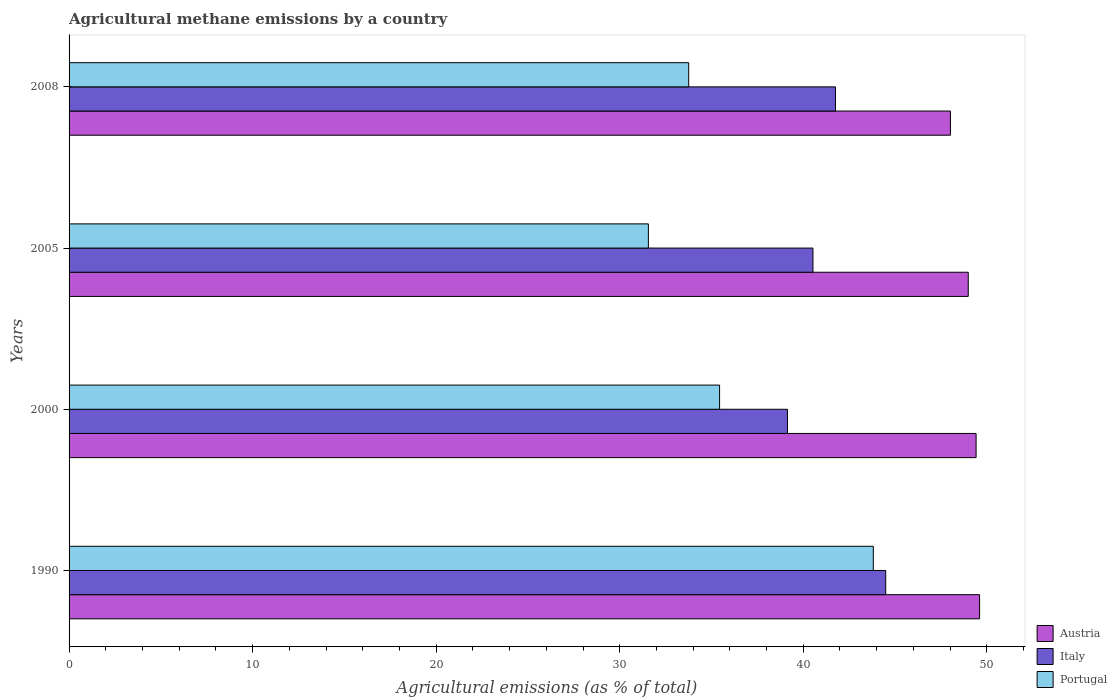How many groups of bars are there?
Keep it short and to the point. 4. How many bars are there on the 4th tick from the top?
Your response must be concise. 3. What is the label of the 4th group of bars from the top?
Provide a succinct answer. 1990. In how many cases, is the number of bars for a given year not equal to the number of legend labels?
Provide a short and direct response. 0. What is the amount of agricultural methane emitted in Portugal in 2000?
Give a very brief answer. 35.44. Across all years, what is the maximum amount of agricultural methane emitted in Austria?
Offer a terse response. 49.61. Across all years, what is the minimum amount of agricultural methane emitted in Italy?
Give a very brief answer. 39.14. In which year was the amount of agricultural methane emitted in Austria maximum?
Offer a very short reply. 1990. What is the total amount of agricultural methane emitted in Portugal in the graph?
Your response must be concise. 144.58. What is the difference between the amount of agricultural methane emitted in Portugal in 1990 and that in 2000?
Make the answer very short. 8.38. What is the difference between the amount of agricultural methane emitted in Austria in 2000 and the amount of agricultural methane emitted in Portugal in 2008?
Keep it short and to the point. 15.66. What is the average amount of agricultural methane emitted in Portugal per year?
Provide a short and direct response. 36.14. In the year 1990, what is the difference between the amount of agricultural methane emitted in Italy and amount of agricultural methane emitted in Austria?
Ensure brevity in your answer.  -5.11. In how many years, is the amount of agricultural methane emitted in Italy greater than 44 %?
Your answer should be compact. 1. What is the ratio of the amount of agricultural methane emitted in Portugal in 2005 to that in 2008?
Your response must be concise. 0.93. Is the difference between the amount of agricultural methane emitted in Italy in 1990 and 2000 greater than the difference between the amount of agricultural methane emitted in Austria in 1990 and 2000?
Make the answer very short. Yes. What is the difference between the highest and the second highest amount of agricultural methane emitted in Portugal?
Offer a very short reply. 8.38. What is the difference between the highest and the lowest amount of agricultural methane emitted in Portugal?
Your answer should be very brief. 12.26. Is the sum of the amount of agricultural methane emitted in Italy in 2000 and 2005 greater than the maximum amount of agricultural methane emitted in Portugal across all years?
Make the answer very short. Yes. What does the 3rd bar from the top in 2005 represents?
Provide a short and direct response. Austria. How many bars are there?
Offer a terse response. 12. Are all the bars in the graph horizontal?
Provide a succinct answer. Yes. What is the difference between two consecutive major ticks on the X-axis?
Ensure brevity in your answer.  10. Are the values on the major ticks of X-axis written in scientific E-notation?
Make the answer very short. No. Does the graph contain grids?
Offer a very short reply. No. Where does the legend appear in the graph?
Your answer should be compact. Bottom right. How many legend labels are there?
Provide a short and direct response. 3. How are the legend labels stacked?
Ensure brevity in your answer.  Vertical. What is the title of the graph?
Keep it short and to the point. Agricultural methane emissions by a country. What is the label or title of the X-axis?
Keep it short and to the point. Agricultural emissions (as % of total). What is the label or title of the Y-axis?
Provide a short and direct response. Years. What is the Agricultural emissions (as % of total) in Austria in 1990?
Provide a succinct answer. 49.61. What is the Agricultural emissions (as % of total) in Italy in 1990?
Offer a terse response. 44.49. What is the Agricultural emissions (as % of total) in Portugal in 1990?
Keep it short and to the point. 43.82. What is the Agricultural emissions (as % of total) in Austria in 2000?
Offer a terse response. 49.42. What is the Agricultural emissions (as % of total) of Italy in 2000?
Provide a short and direct response. 39.14. What is the Agricultural emissions (as % of total) in Portugal in 2000?
Provide a succinct answer. 35.44. What is the Agricultural emissions (as % of total) in Austria in 2005?
Offer a very short reply. 48.99. What is the Agricultural emissions (as % of total) in Italy in 2005?
Provide a succinct answer. 40.53. What is the Agricultural emissions (as % of total) of Portugal in 2005?
Provide a succinct answer. 31.56. What is the Agricultural emissions (as % of total) of Austria in 2008?
Offer a terse response. 48.02. What is the Agricultural emissions (as % of total) of Italy in 2008?
Keep it short and to the point. 41.76. What is the Agricultural emissions (as % of total) in Portugal in 2008?
Provide a succinct answer. 33.76. Across all years, what is the maximum Agricultural emissions (as % of total) of Austria?
Provide a succinct answer. 49.61. Across all years, what is the maximum Agricultural emissions (as % of total) of Italy?
Keep it short and to the point. 44.49. Across all years, what is the maximum Agricultural emissions (as % of total) of Portugal?
Offer a terse response. 43.82. Across all years, what is the minimum Agricultural emissions (as % of total) of Austria?
Provide a short and direct response. 48.02. Across all years, what is the minimum Agricultural emissions (as % of total) in Italy?
Give a very brief answer. 39.14. Across all years, what is the minimum Agricultural emissions (as % of total) of Portugal?
Give a very brief answer. 31.56. What is the total Agricultural emissions (as % of total) in Austria in the graph?
Your answer should be very brief. 196.03. What is the total Agricultural emissions (as % of total) in Italy in the graph?
Make the answer very short. 165.92. What is the total Agricultural emissions (as % of total) in Portugal in the graph?
Give a very brief answer. 144.58. What is the difference between the Agricultural emissions (as % of total) in Austria in 1990 and that in 2000?
Offer a terse response. 0.19. What is the difference between the Agricultural emissions (as % of total) of Italy in 1990 and that in 2000?
Offer a very short reply. 5.35. What is the difference between the Agricultural emissions (as % of total) in Portugal in 1990 and that in 2000?
Keep it short and to the point. 8.38. What is the difference between the Agricultural emissions (as % of total) in Austria in 1990 and that in 2005?
Keep it short and to the point. 0.62. What is the difference between the Agricultural emissions (as % of total) of Italy in 1990 and that in 2005?
Provide a short and direct response. 3.96. What is the difference between the Agricultural emissions (as % of total) in Portugal in 1990 and that in 2005?
Provide a short and direct response. 12.26. What is the difference between the Agricultural emissions (as % of total) in Austria in 1990 and that in 2008?
Your response must be concise. 1.59. What is the difference between the Agricultural emissions (as % of total) of Italy in 1990 and that in 2008?
Offer a very short reply. 2.74. What is the difference between the Agricultural emissions (as % of total) in Portugal in 1990 and that in 2008?
Your answer should be compact. 10.06. What is the difference between the Agricultural emissions (as % of total) of Austria in 2000 and that in 2005?
Your response must be concise. 0.43. What is the difference between the Agricultural emissions (as % of total) in Italy in 2000 and that in 2005?
Your answer should be very brief. -1.39. What is the difference between the Agricultural emissions (as % of total) in Portugal in 2000 and that in 2005?
Make the answer very short. 3.88. What is the difference between the Agricultural emissions (as % of total) of Austria in 2000 and that in 2008?
Keep it short and to the point. 1.4. What is the difference between the Agricultural emissions (as % of total) in Italy in 2000 and that in 2008?
Your answer should be very brief. -2.62. What is the difference between the Agricultural emissions (as % of total) of Portugal in 2000 and that in 2008?
Your response must be concise. 1.68. What is the difference between the Agricultural emissions (as % of total) of Austria in 2005 and that in 2008?
Keep it short and to the point. 0.97. What is the difference between the Agricultural emissions (as % of total) in Italy in 2005 and that in 2008?
Provide a succinct answer. -1.23. What is the difference between the Agricultural emissions (as % of total) of Portugal in 2005 and that in 2008?
Your response must be concise. -2.2. What is the difference between the Agricultural emissions (as % of total) of Austria in 1990 and the Agricultural emissions (as % of total) of Italy in 2000?
Your answer should be compact. 10.47. What is the difference between the Agricultural emissions (as % of total) in Austria in 1990 and the Agricultural emissions (as % of total) in Portugal in 2000?
Ensure brevity in your answer.  14.17. What is the difference between the Agricultural emissions (as % of total) of Italy in 1990 and the Agricultural emissions (as % of total) of Portugal in 2000?
Give a very brief answer. 9.05. What is the difference between the Agricultural emissions (as % of total) of Austria in 1990 and the Agricultural emissions (as % of total) of Italy in 2005?
Provide a short and direct response. 9.08. What is the difference between the Agricultural emissions (as % of total) in Austria in 1990 and the Agricultural emissions (as % of total) in Portugal in 2005?
Make the answer very short. 18.04. What is the difference between the Agricultural emissions (as % of total) of Italy in 1990 and the Agricultural emissions (as % of total) of Portugal in 2005?
Keep it short and to the point. 12.93. What is the difference between the Agricultural emissions (as % of total) of Austria in 1990 and the Agricultural emissions (as % of total) of Italy in 2008?
Provide a succinct answer. 7.85. What is the difference between the Agricultural emissions (as % of total) of Austria in 1990 and the Agricultural emissions (as % of total) of Portugal in 2008?
Offer a very short reply. 15.85. What is the difference between the Agricultural emissions (as % of total) of Italy in 1990 and the Agricultural emissions (as % of total) of Portugal in 2008?
Your response must be concise. 10.73. What is the difference between the Agricultural emissions (as % of total) in Austria in 2000 and the Agricultural emissions (as % of total) in Italy in 2005?
Provide a succinct answer. 8.89. What is the difference between the Agricultural emissions (as % of total) in Austria in 2000 and the Agricultural emissions (as % of total) in Portugal in 2005?
Offer a terse response. 17.86. What is the difference between the Agricultural emissions (as % of total) of Italy in 2000 and the Agricultural emissions (as % of total) of Portugal in 2005?
Offer a terse response. 7.58. What is the difference between the Agricultural emissions (as % of total) in Austria in 2000 and the Agricultural emissions (as % of total) in Italy in 2008?
Offer a terse response. 7.66. What is the difference between the Agricultural emissions (as % of total) of Austria in 2000 and the Agricultural emissions (as % of total) of Portugal in 2008?
Provide a succinct answer. 15.66. What is the difference between the Agricultural emissions (as % of total) of Italy in 2000 and the Agricultural emissions (as % of total) of Portugal in 2008?
Offer a terse response. 5.38. What is the difference between the Agricultural emissions (as % of total) in Austria in 2005 and the Agricultural emissions (as % of total) in Italy in 2008?
Keep it short and to the point. 7.23. What is the difference between the Agricultural emissions (as % of total) in Austria in 2005 and the Agricultural emissions (as % of total) in Portugal in 2008?
Make the answer very short. 15.23. What is the difference between the Agricultural emissions (as % of total) in Italy in 2005 and the Agricultural emissions (as % of total) in Portugal in 2008?
Give a very brief answer. 6.77. What is the average Agricultural emissions (as % of total) of Austria per year?
Offer a very short reply. 49.01. What is the average Agricultural emissions (as % of total) in Italy per year?
Provide a succinct answer. 41.48. What is the average Agricultural emissions (as % of total) of Portugal per year?
Provide a succinct answer. 36.14. In the year 1990, what is the difference between the Agricultural emissions (as % of total) in Austria and Agricultural emissions (as % of total) in Italy?
Provide a short and direct response. 5.11. In the year 1990, what is the difference between the Agricultural emissions (as % of total) of Austria and Agricultural emissions (as % of total) of Portugal?
Your response must be concise. 5.79. In the year 1990, what is the difference between the Agricultural emissions (as % of total) in Italy and Agricultural emissions (as % of total) in Portugal?
Provide a succinct answer. 0.68. In the year 2000, what is the difference between the Agricultural emissions (as % of total) in Austria and Agricultural emissions (as % of total) in Italy?
Keep it short and to the point. 10.28. In the year 2000, what is the difference between the Agricultural emissions (as % of total) in Austria and Agricultural emissions (as % of total) in Portugal?
Offer a very short reply. 13.98. In the year 2000, what is the difference between the Agricultural emissions (as % of total) in Italy and Agricultural emissions (as % of total) in Portugal?
Offer a terse response. 3.7. In the year 2005, what is the difference between the Agricultural emissions (as % of total) in Austria and Agricultural emissions (as % of total) in Italy?
Your response must be concise. 8.46. In the year 2005, what is the difference between the Agricultural emissions (as % of total) of Austria and Agricultural emissions (as % of total) of Portugal?
Ensure brevity in your answer.  17.43. In the year 2005, what is the difference between the Agricultural emissions (as % of total) of Italy and Agricultural emissions (as % of total) of Portugal?
Your answer should be compact. 8.97. In the year 2008, what is the difference between the Agricultural emissions (as % of total) in Austria and Agricultural emissions (as % of total) in Italy?
Make the answer very short. 6.26. In the year 2008, what is the difference between the Agricultural emissions (as % of total) of Austria and Agricultural emissions (as % of total) of Portugal?
Offer a very short reply. 14.26. In the year 2008, what is the difference between the Agricultural emissions (as % of total) of Italy and Agricultural emissions (as % of total) of Portugal?
Your answer should be compact. 8. What is the ratio of the Agricultural emissions (as % of total) in Austria in 1990 to that in 2000?
Keep it short and to the point. 1. What is the ratio of the Agricultural emissions (as % of total) in Italy in 1990 to that in 2000?
Provide a short and direct response. 1.14. What is the ratio of the Agricultural emissions (as % of total) in Portugal in 1990 to that in 2000?
Your answer should be very brief. 1.24. What is the ratio of the Agricultural emissions (as % of total) of Austria in 1990 to that in 2005?
Give a very brief answer. 1.01. What is the ratio of the Agricultural emissions (as % of total) of Italy in 1990 to that in 2005?
Offer a terse response. 1.1. What is the ratio of the Agricultural emissions (as % of total) of Portugal in 1990 to that in 2005?
Make the answer very short. 1.39. What is the ratio of the Agricultural emissions (as % of total) in Austria in 1990 to that in 2008?
Your answer should be very brief. 1.03. What is the ratio of the Agricultural emissions (as % of total) in Italy in 1990 to that in 2008?
Your answer should be very brief. 1.07. What is the ratio of the Agricultural emissions (as % of total) of Portugal in 1990 to that in 2008?
Your answer should be compact. 1.3. What is the ratio of the Agricultural emissions (as % of total) in Austria in 2000 to that in 2005?
Your answer should be compact. 1.01. What is the ratio of the Agricultural emissions (as % of total) in Italy in 2000 to that in 2005?
Your answer should be very brief. 0.97. What is the ratio of the Agricultural emissions (as % of total) in Portugal in 2000 to that in 2005?
Ensure brevity in your answer.  1.12. What is the ratio of the Agricultural emissions (as % of total) in Austria in 2000 to that in 2008?
Offer a terse response. 1.03. What is the ratio of the Agricultural emissions (as % of total) in Italy in 2000 to that in 2008?
Keep it short and to the point. 0.94. What is the ratio of the Agricultural emissions (as % of total) of Portugal in 2000 to that in 2008?
Your response must be concise. 1.05. What is the ratio of the Agricultural emissions (as % of total) of Austria in 2005 to that in 2008?
Give a very brief answer. 1.02. What is the ratio of the Agricultural emissions (as % of total) in Italy in 2005 to that in 2008?
Give a very brief answer. 0.97. What is the ratio of the Agricultural emissions (as % of total) of Portugal in 2005 to that in 2008?
Provide a succinct answer. 0.93. What is the difference between the highest and the second highest Agricultural emissions (as % of total) of Austria?
Your response must be concise. 0.19. What is the difference between the highest and the second highest Agricultural emissions (as % of total) of Italy?
Make the answer very short. 2.74. What is the difference between the highest and the second highest Agricultural emissions (as % of total) in Portugal?
Your answer should be compact. 8.38. What is the difference between the highest and the lowest Agricultural emissions (as % of total) of Austria?
Provide a succinct answer. 1.59. What is the difference between the highest and the lowest Agricultural emissions (as % of total) of Italy?
Provide a succinct answer. 5.35. What is the difference between the highest and the lowest Agricultural emissions (as % of total) in Portugal?
Make the answer very short. 12.26. 